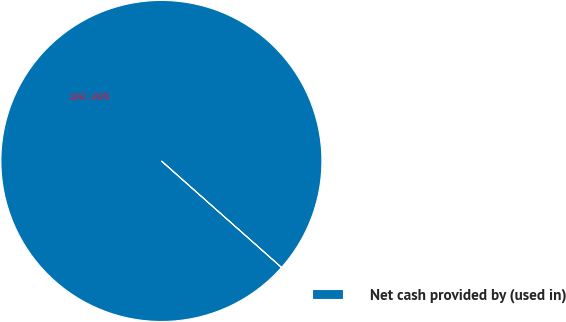Convert chart. <chart><loc_0><loc_0><loc_500><loc_500><pie_chart><fcel>Net cash provided by (used in)<nl><fcel>100.0%<nl></chart> 